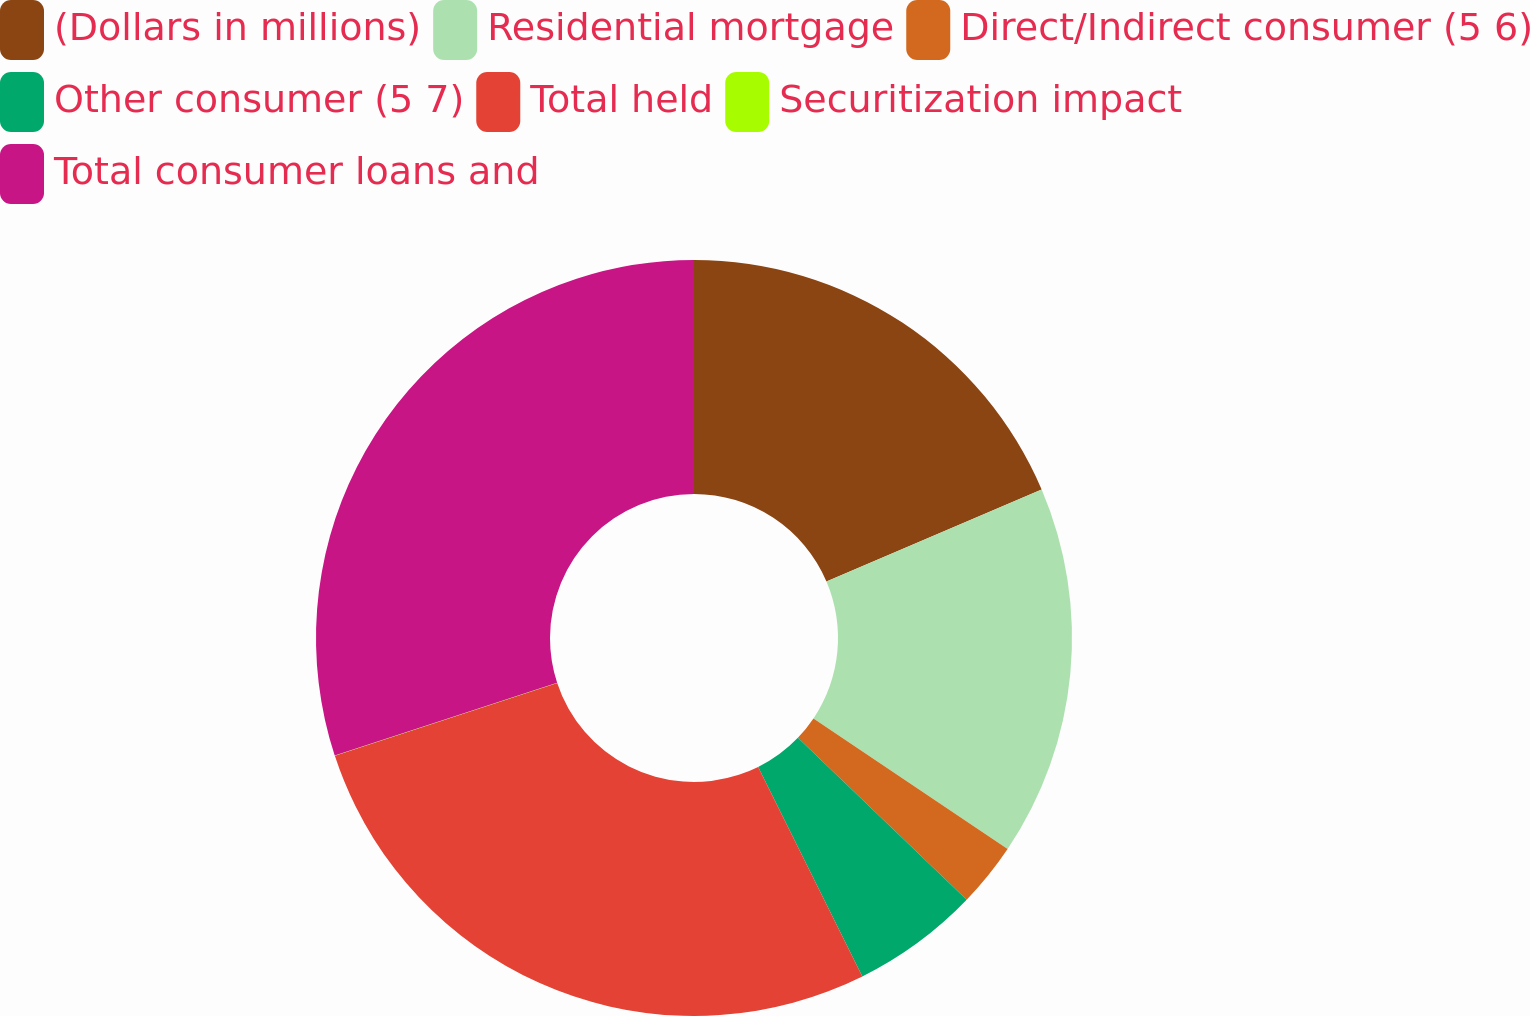<chart> <loc_0><loc_0><loc_500><loc_500><pie_chart><fcel>(Dollars in millions)<fcel>Residential mortgage<fcel>Direct/Indirect consumer (5 6)<fcel>Other consumer (5 7)<fcel>Total held<fcel>Securitization impact<fcel>Total consumer loans and<nl><fcel>18.58%<fcel>15.85%<fcel>2.75%<fcel>5.48%<fcel>27.3%<fcel>0.02%<fcel>30.03%<nl></chart> 